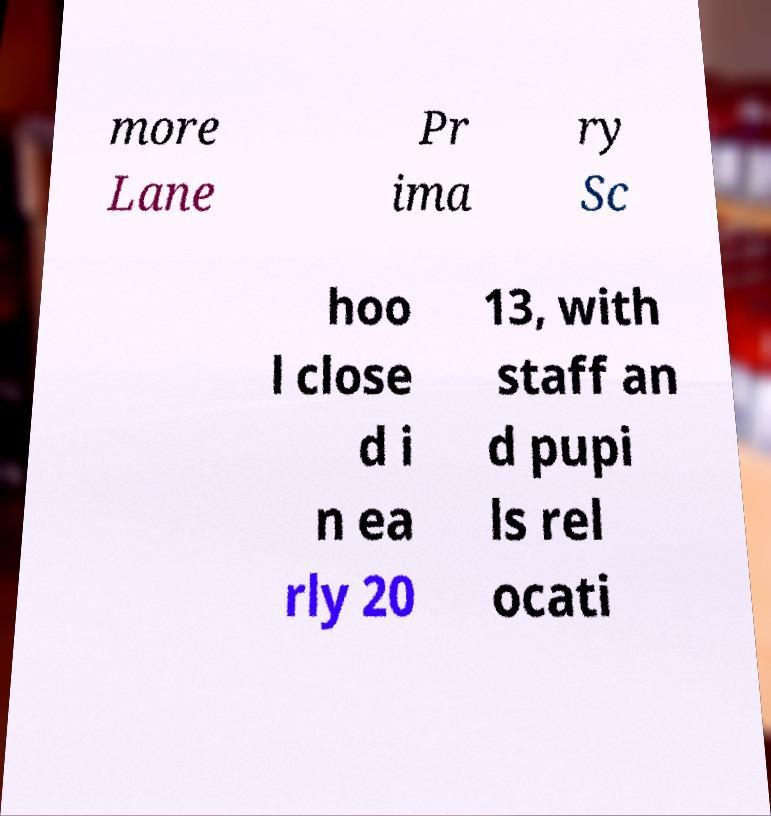For documentation purposes, I need the text within this image transcribed. Could you provide that? more Lane Pr ima ry Sc hoo l close d i n ea rly 20 13, with staff an d pupi ls rel ocati 